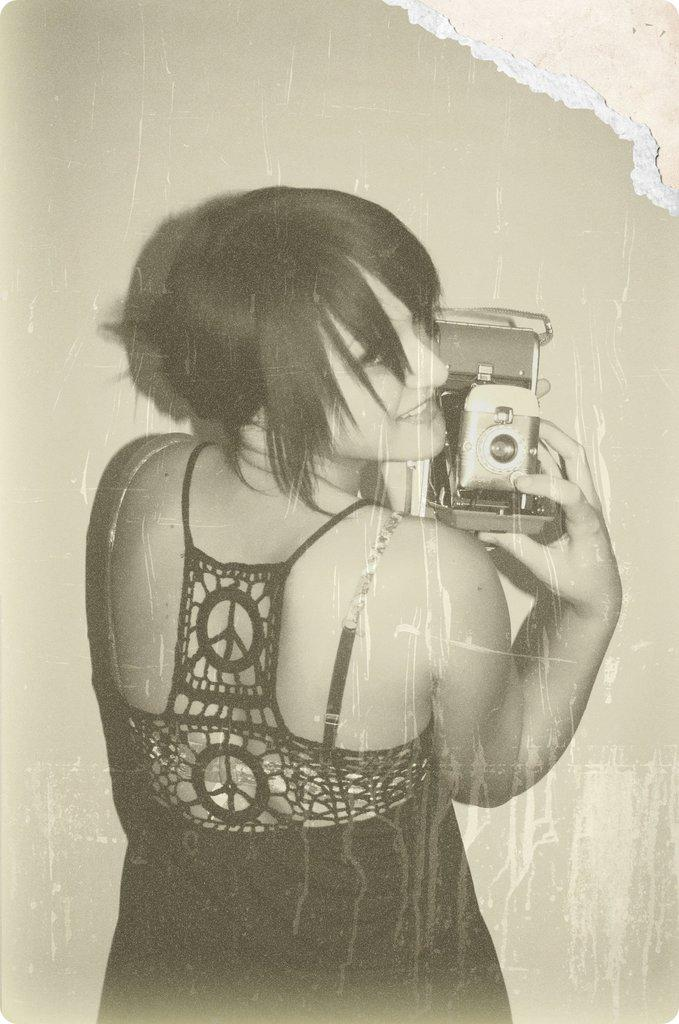What is the color scheme of the image? The image is black and white. Who is present in the image? There is a woman in the image. What is the woman doing in the image? The woman is standing and smiling. What is the woman holding in the image? The woman is holding a camera in her hands. Can you describe the condition of the image? The image appears to be physically damaged, with a tear at the corner. What historical event is the woman attending in the image? There is no indication of a specific historical event in the image; it simply shows a woman standing and smiling while holding a camera. Can you tell me how many carts are visible in the image? There are no carts present in the image. 